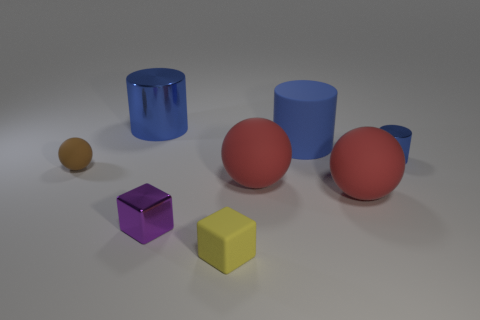There is a purple object that is to the left of the big blue object in front of the large blue metallic thing; what number of yellow matte things are to the left of it?
Your answer should be compact. 0. What number of big blue objects are behind the yellow cube?
Offer a terse response. 2. What number of tiny brown spheres are made of the same material as the small yellow thing?
Give a very brief answer. 1. What color is the small block that is the same material as the small ball?
Provide a short and direct response. Yellow. The sphere that is left of the tiny purple shiny object left of the matte object that is behind the tiny cylinder is made of what material?
Offer a terse response. Rubber. There is a shiny object in front of the brown ball; is its size the same as the brown sphere?
Offer a terse response. Yes. What number of tiny things are either rubber cubes or gray matte cylinders?
Keep it short and to the point. 1. Are there any tiny matte blocks of the same color as the big rubber cylinder?
Give a very brief answer. No. What is the shape of the blue thing that is the same size as the brown sphere?
Give a very brief answer. Cylinder. There is a big matte thing behind the tiny blue object; does it have the same color as the big metal cylinder?
Offer a terse response. Yes. 